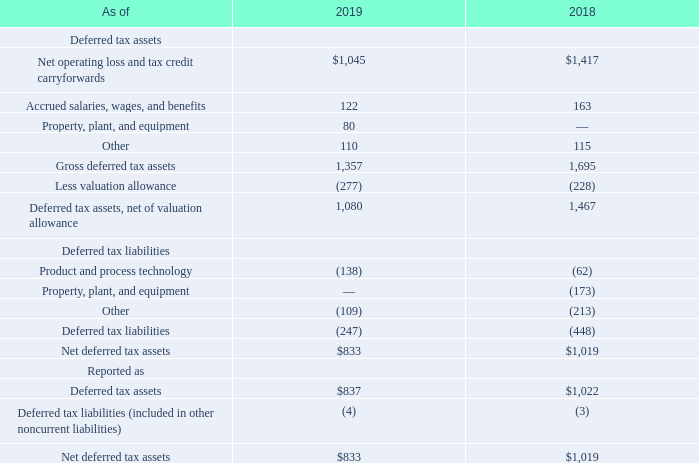Deferred income taxes reflect the net tax effects of temporary differences between the bases of assets and liabilities for financial reporting and income tax purposes as well as carryforwards. Deferred tax assets and liabilities consist of the following:
We assess positive and negative evidence for each jurisdiction to determine whether it is more likely than not that existing deferred tax assets will be realized. As of August 29, 2019, and August 30, 2018, we had a valuation allowance of $277 million and $228 million, respectively, against our net deferred tax assets, primarily related to net operating loss carryforwards in Japan. Changes in 2019 in the valuation allowance were due to adjustments based on management's assessment of tax credits and net operating losses that are more likely than not to be realized.
What do the deferred income taxes reflect? The net tax effects of temporary differences between the bases of assets and liabilities for financial reporting and income tax purposes as well as carryforwards. What caused the change in valuation allowance in 2019? Adjustments based on management's assessment of tax credits and net operating losses that are more likely than not to be realized. What is the amount of net deferred tax assets in 2018?
Answer scale should be: million. $1,019. What is the percentage change in the amount of net deferred tax assets from 2018 to 2019?
Answer scale should be: percent. ($833-$1,019)/1,019 
Answer: -18.25. What is the difference between the amount of gross deferred tax assets in 2018 and 2019?
Answer scale should be: million. 1,695-1,357 
Answer: 338. What is the ratio of the amount of net deferred tax liabilities in 2018 over 2019? -448/-247 
Answer: 1.81. 